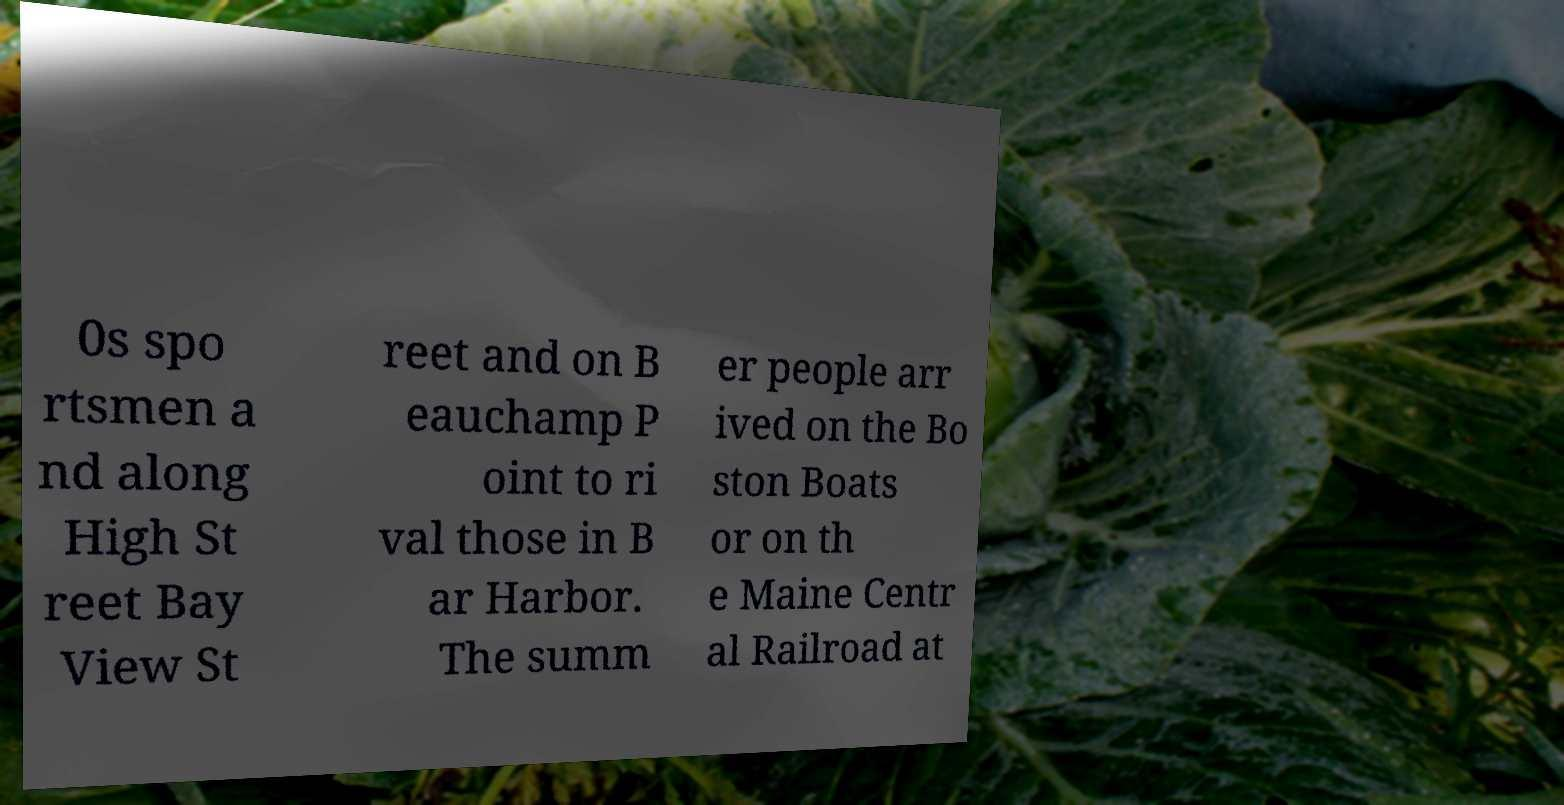Could you extract and type out the text from this image? 0s spo rtsmen a nd along High St reet Bay View St reet and on B eauchamp P oint to ri val those in B ar Harbor. The summ er people arr ived on the Bo ston Boats or on th e Maine Centr al Railroad at 